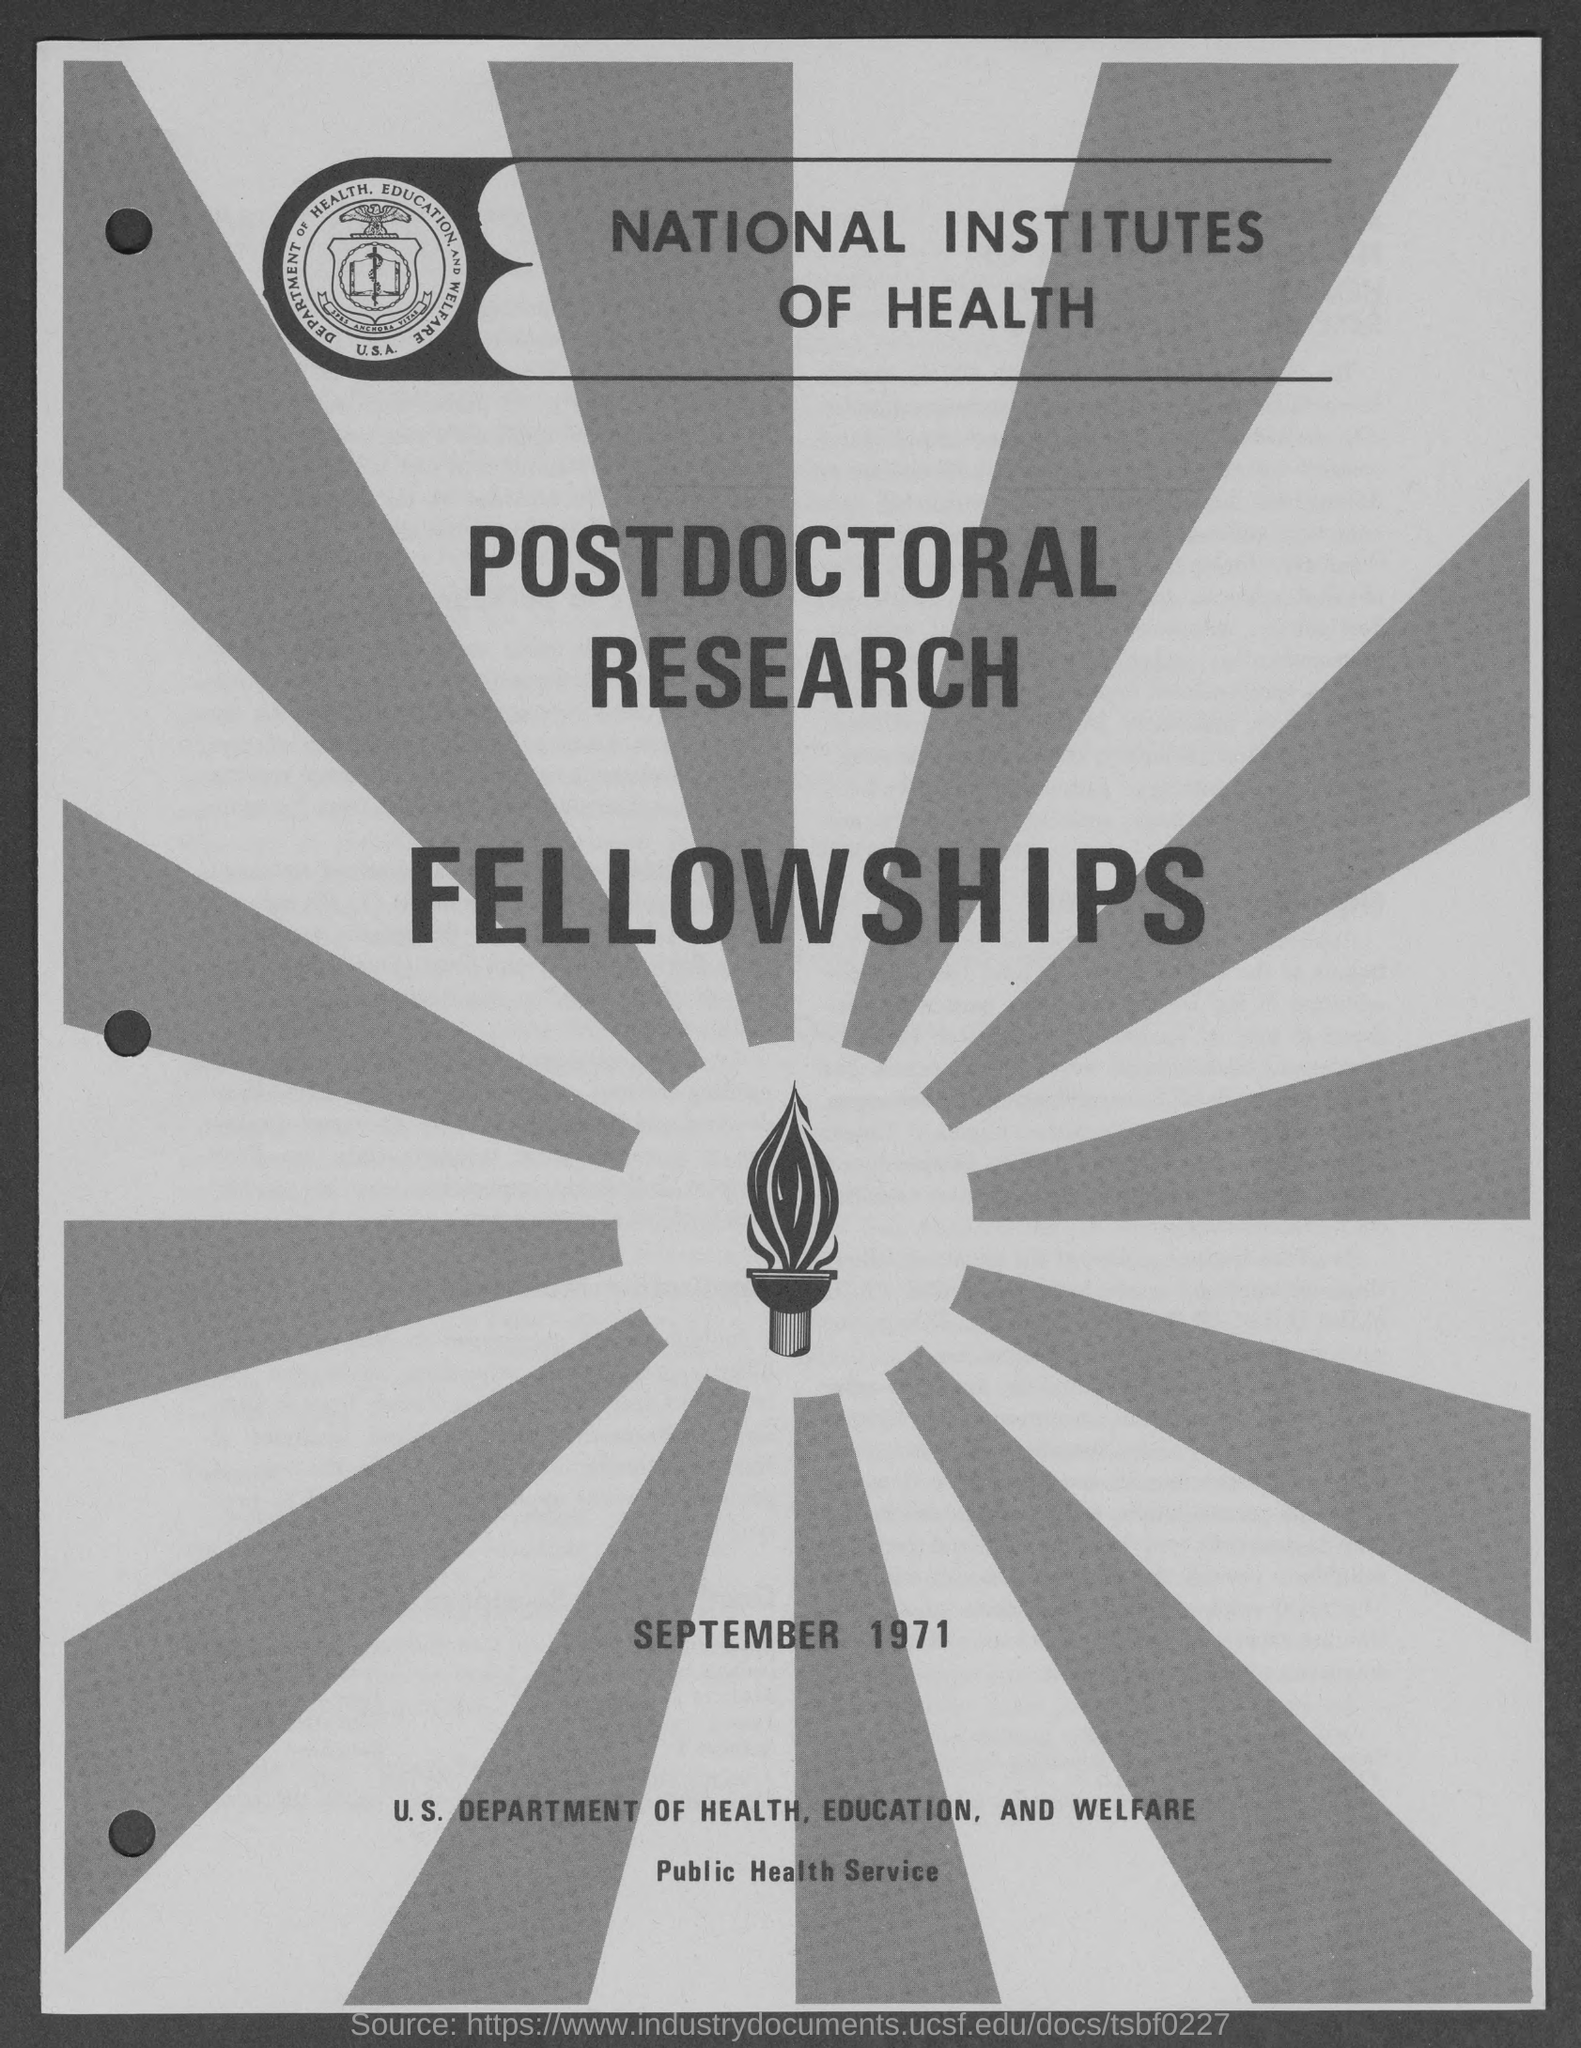When is the document dated?
Offer a terse response. SEPTEMBER 1971. What is the title of the document?
Your response must be concise. NATIONAL INSTITUTES OF HEALTH. 